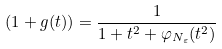Convert formula to latex. <formula><loc_0><loc_0><loc_500><loc_500>( 1 + g ( t ) ) = \frac { 1 } { 1 + t ^ { 2 } + \varphi _ { N _ { \varepsilon } } ( t ^ { 2 } ) }</formula> 